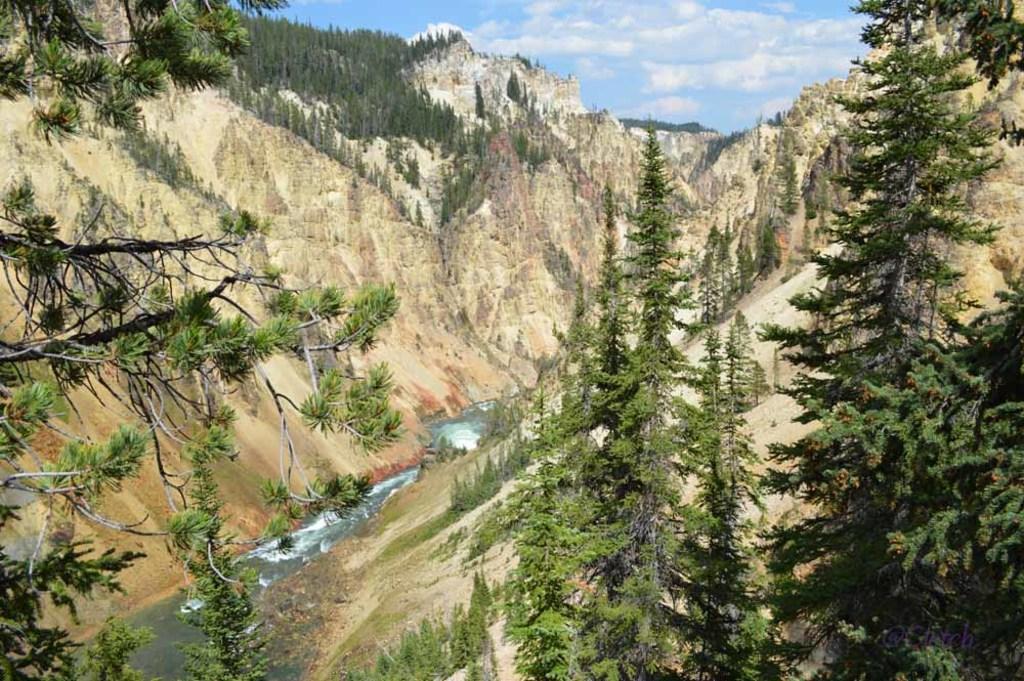In one or two sentences, can you explain what this image depicts? In this image we can see river. To the both sides of the river, mountains are there. On mountain trees are present. At the top of the image sky is there with clouds. 